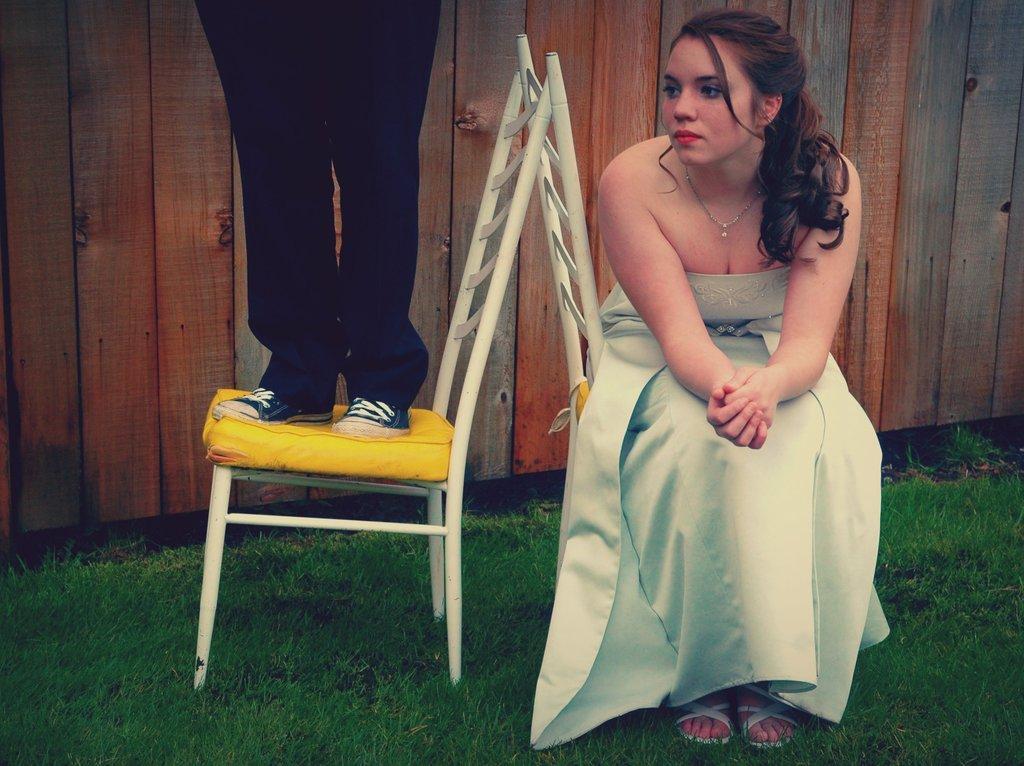Describe this image in one or two sentences. The women is sitting in a chair and there is other person standing on a chair beside her and the ground is greenery. 